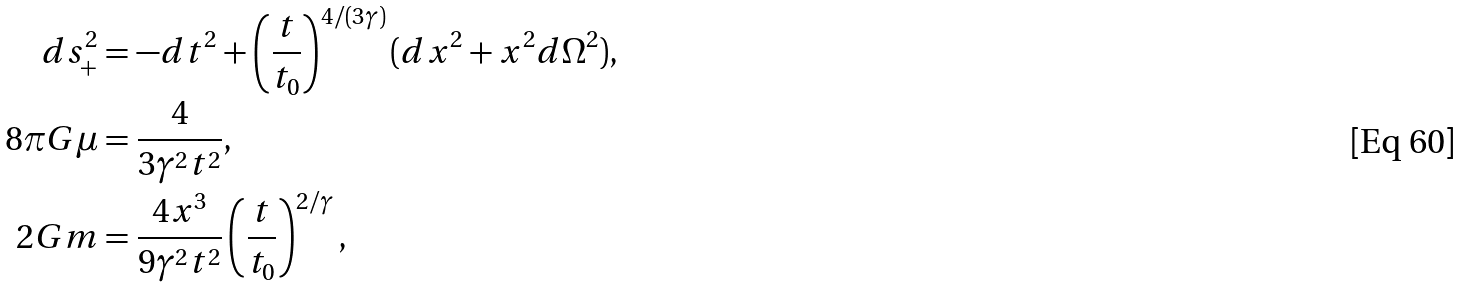Convert formula to latex. <formula><loc_0><loc_0><loc_500><loc_500>d s _ { + } ^ { 2 } & = - d t ^ { 2 } + \left ( \frac { t } { t _ { 0 } } \right ) ^ { 4 / ( 3 \gamma ) } ( d x ^ { 2 } + x ^ { 2 } d \Omega ^ { 2 } ) , \\ 8 \pi G \mu & = \frac { 4 } { 3 \gamma ^ { 2 } t ^ { 2 } } , \\ 2 G m & = \frac { 4 x ^ { 3 } } { 9 \gamma ^ { 2 } t ^ { 2 } } \left ( \frac { t } { t _ { 0 } } \right ) ^ { 2 / \gamma } ,</formula> 